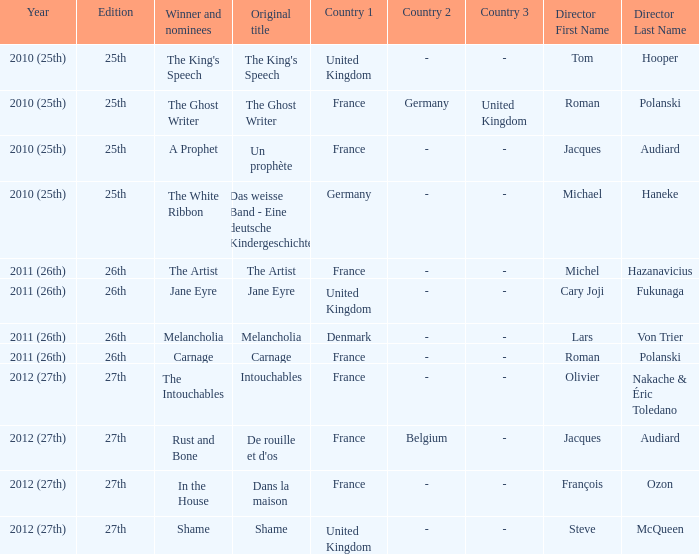Who was the director of the king's speech? Tom Hooper. 